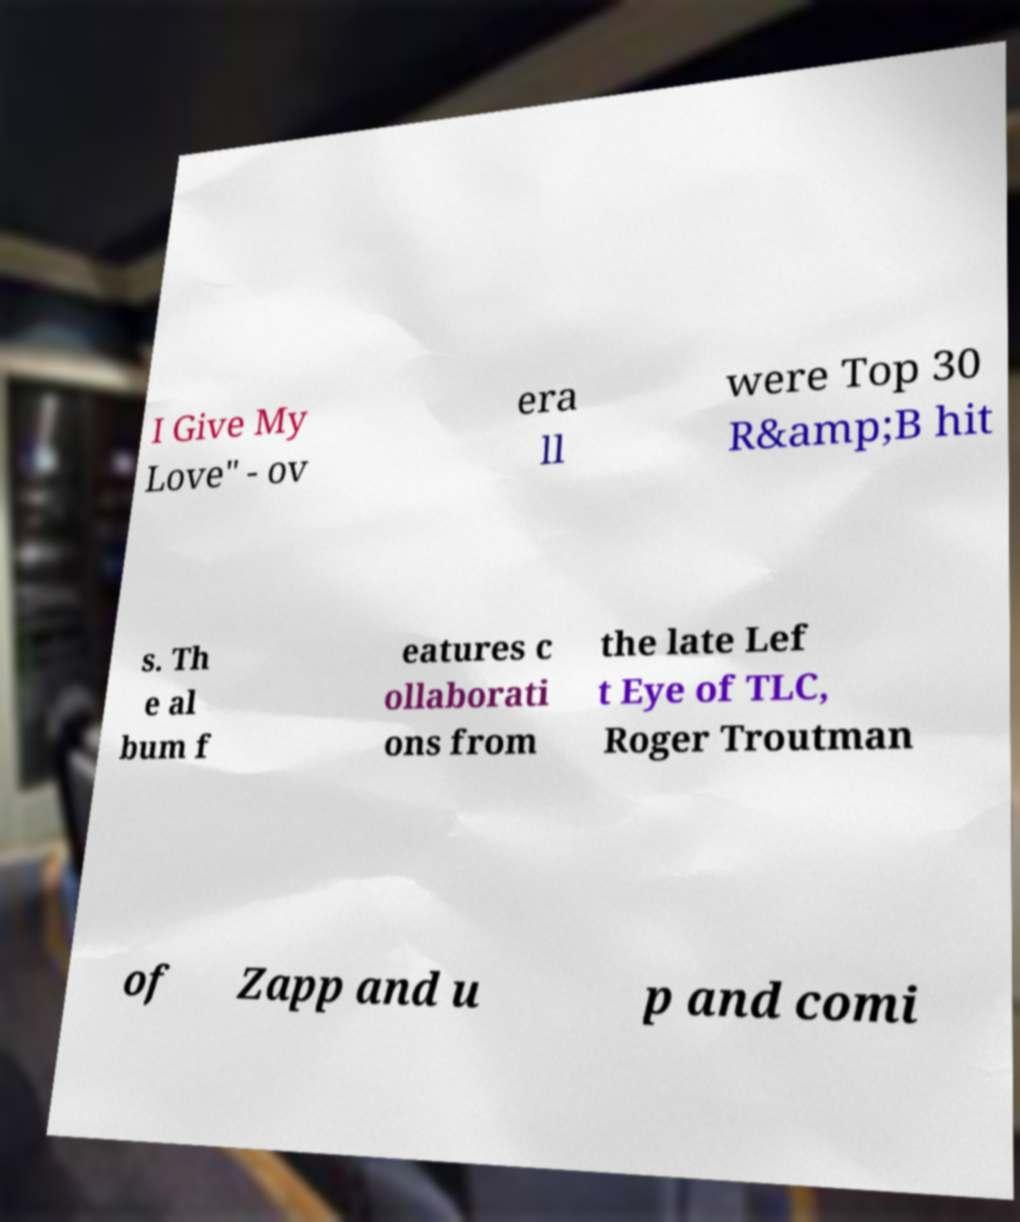Could you extract and type out the text from this image? I Give My Love" - ov era ll were Top 30 R&amp;B hit s. Th e al bum f eatures c ollaborati ons from the late Lef t Eye of TLC, Roger Troutman of Zapp and u p and comi 